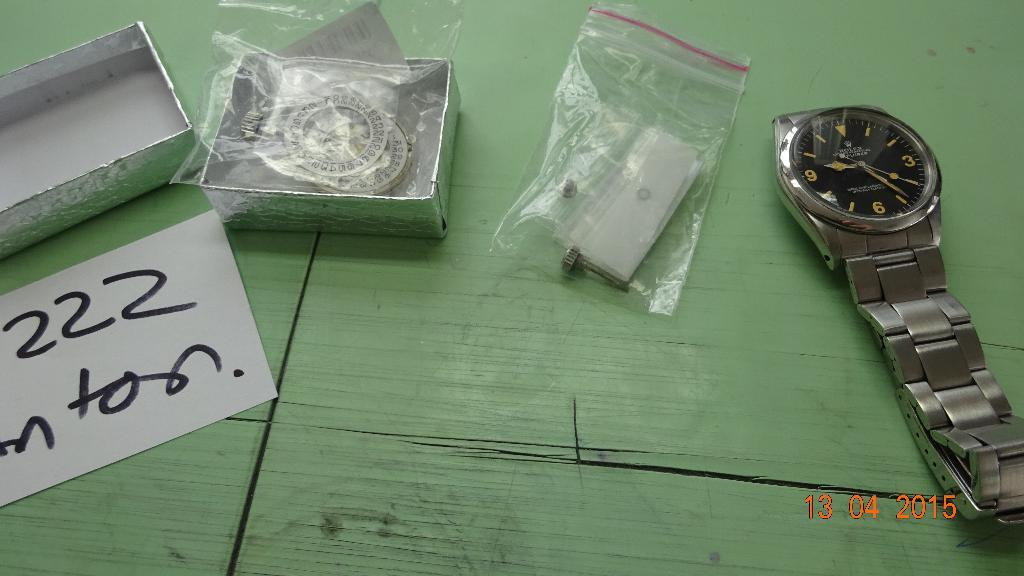Provide a one-sentence caption for the provided image. A watch is next to a bag containing paper and a box with a trinket in it labeled 222 nton. 